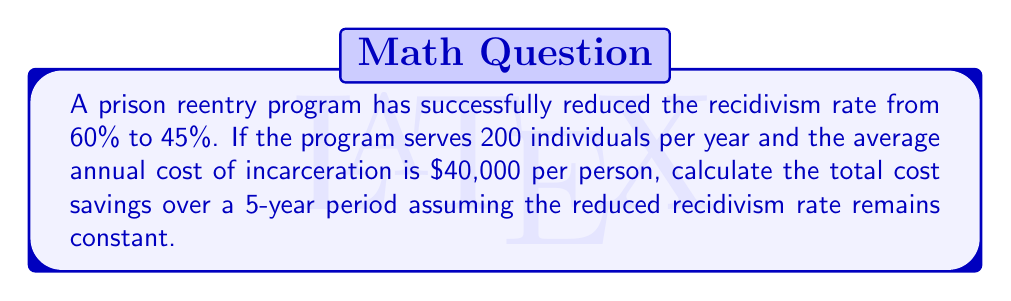What is the answer to this math problem? Let's approach this step-by-step:

1. Calculate the difference in recidivism rates:
   $60\% - 45\% = 15\%$ or $0.15$

2. Determine the number of individuals who avoid reincarceration annually:
   $200 \text{ individuals} \times 0.15 = 30 \text{ individuals}$

3. Calculate the annual cost savings:
   $30 \text{ individuals} \times \$40,000 = \$1,200,000$

4. Compute the total savings over 5 years:
   $\$1,200,000 \times 5 \text{ years} = \$6,000,000$

The calculation can be expressed as a single formula:

$$\text{Total Savings} = N \times (R_1 - R_2) \times C \times Y$$

Where:
$N$ = Number of individuals served per year
$R_1$ = Initial recidivism rate
$R_2$ = Reduced recidivism rate
$C$ = Annual cost of incarceration per person
$Y$ = Number of years

Plugging in our values:

$$\text{Total Savings} = 200 \times (0.60 - 0.45) \times \$40,000 \times 5 = \$6,000,000$$
Answer: $6,000,000 